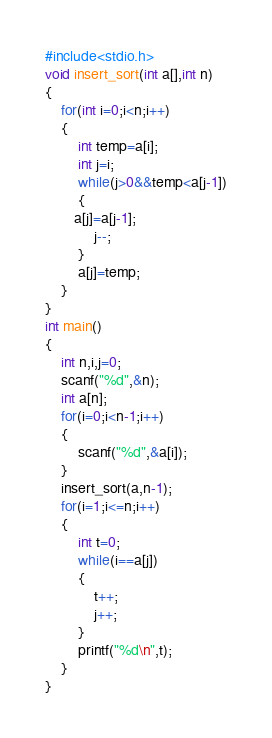<code> <loc_0><loc_0><loc_500><loc_500><_C_>#include<stdio.h>
void insert_sort(int a[],int n)
{
    for(int i=0;i<n;i++)
    {
        int temp=a[i];
        int j=i;
        while(j>0&&temp<a[j-1])
        {
       a[j]=a[j-1];
            j--;
        }
        a[j]=temp;
    }
}
int main()
{
    int n,i,j=0;
    scanf("%d",&n);
    int a[n];
    for(i=0;i<n-1;i++)
    {
        scanf("%d",&a[i]);
    }
    insert_sort(a,n-1);
    for(i=1;i<=n;i++)
    {
        int t=0;
        while(i==a[j])
        {
            t++;
            j++;
        }
        printf("%d\n",t);
    }
}</code> 